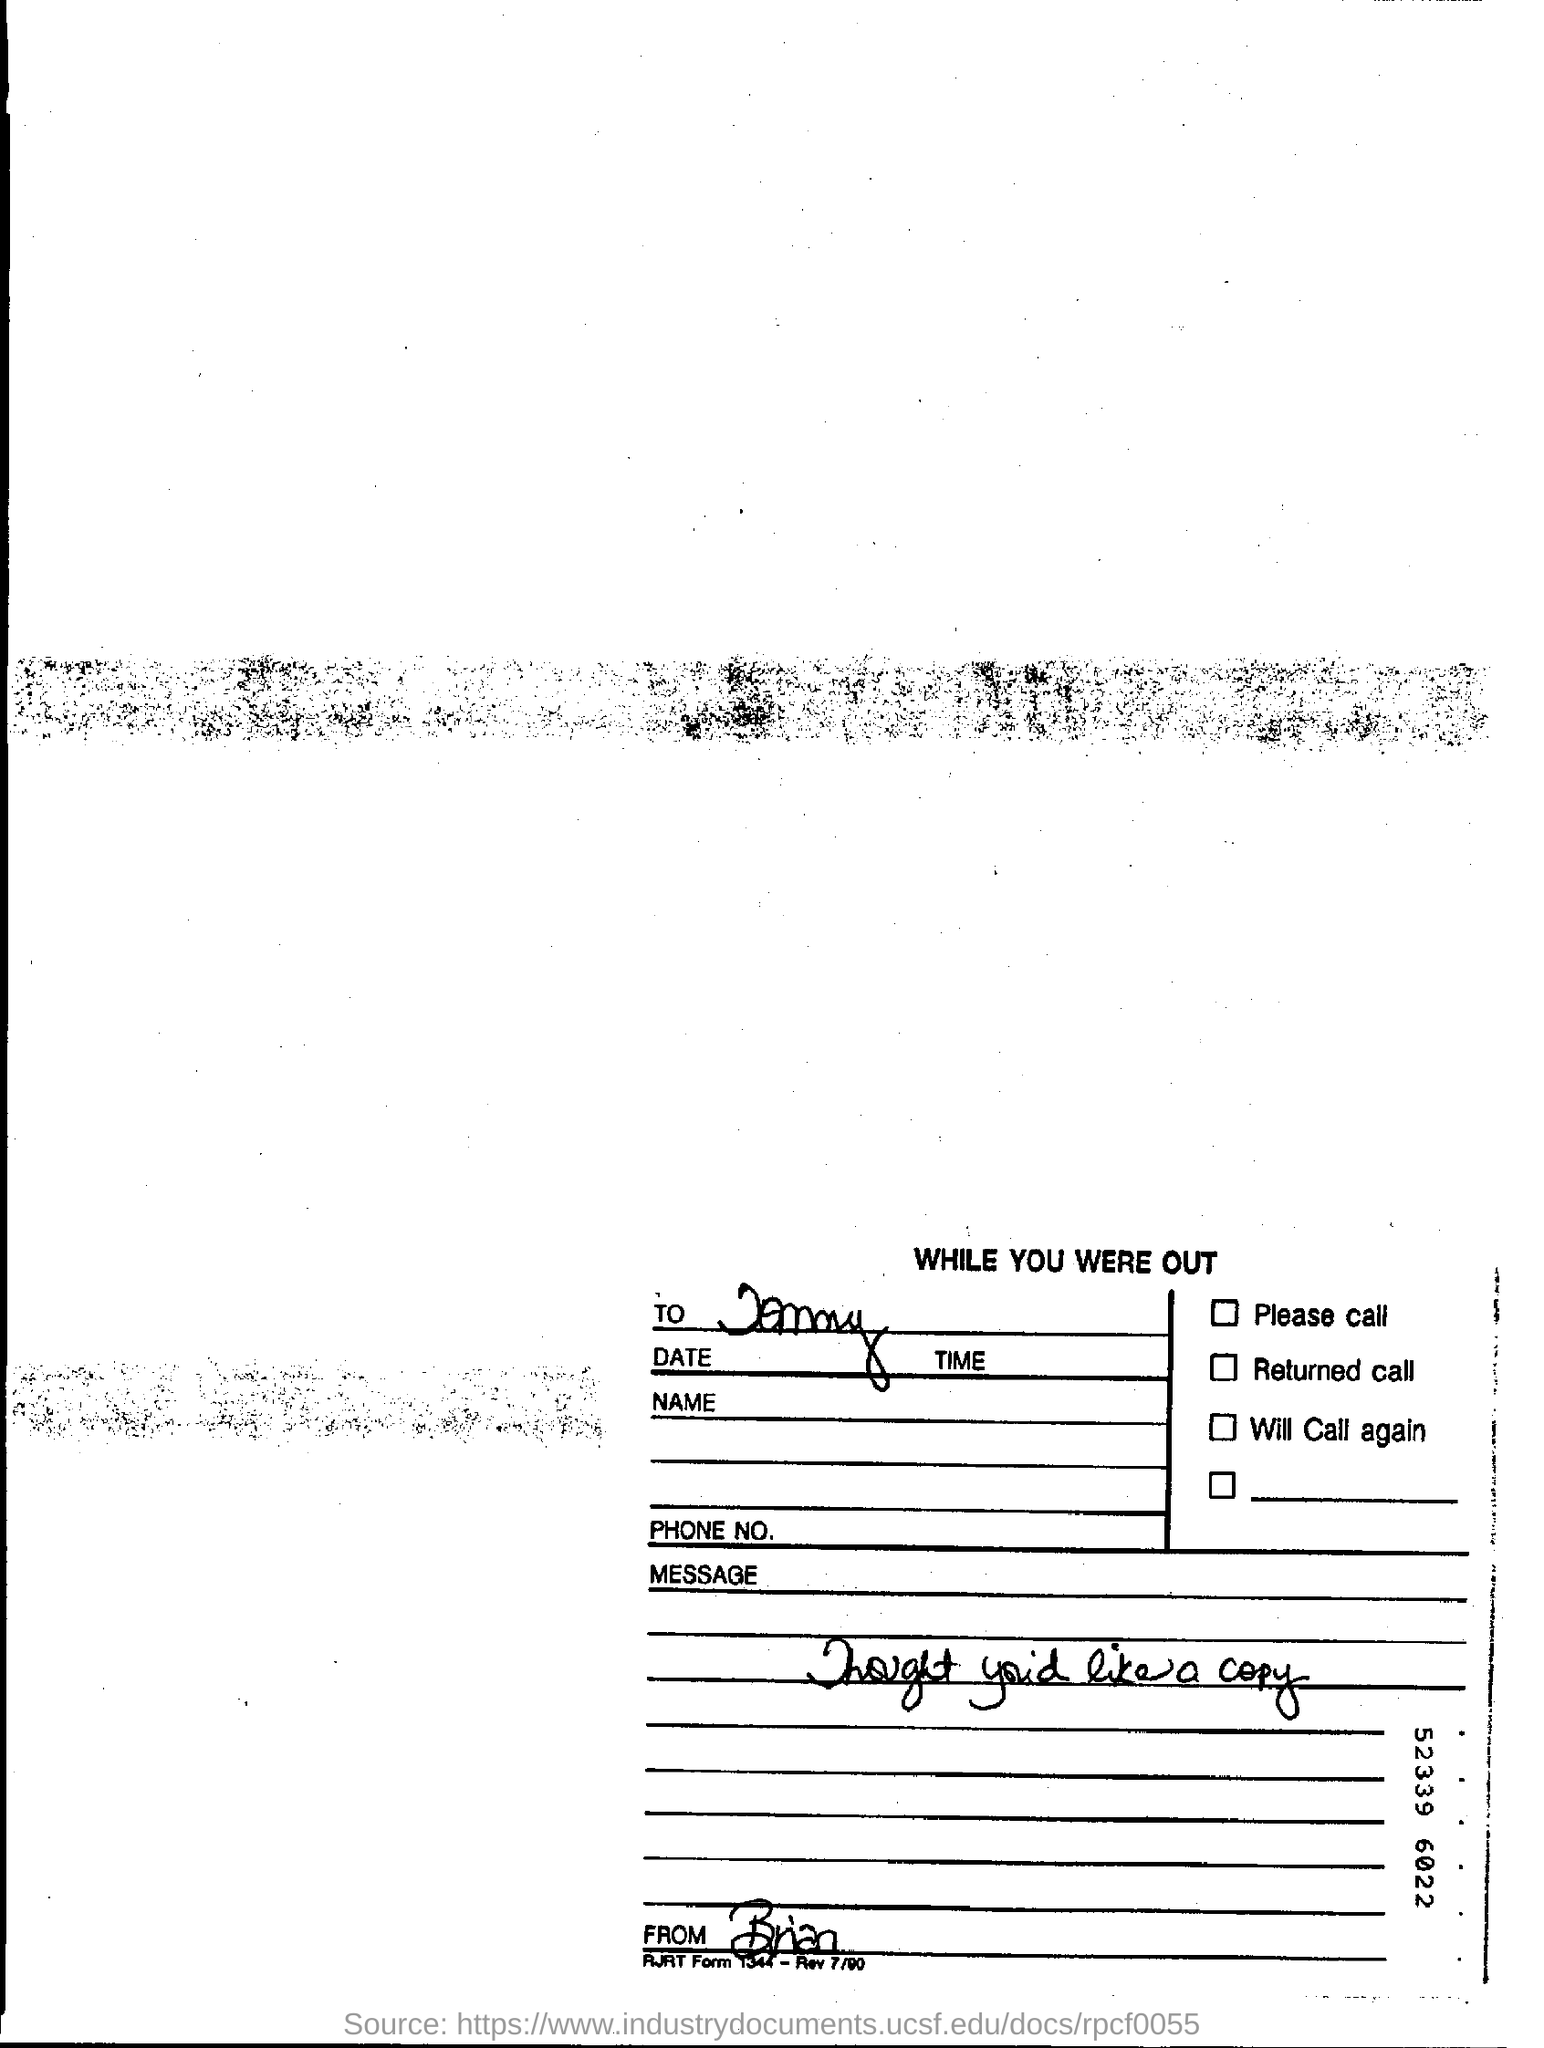Point out several critical features in this image. The writer of this letter is Brian. 